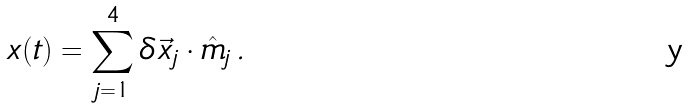Convert formula to latex. <formula><loc_0><loc_0><loc_500><loc_500>x ( t ) = \sum _ { j = 1 } ^ { 4 } \delta \vec { x } _ { j } \cdot \hat { m } _ { j } \, .</formula> 